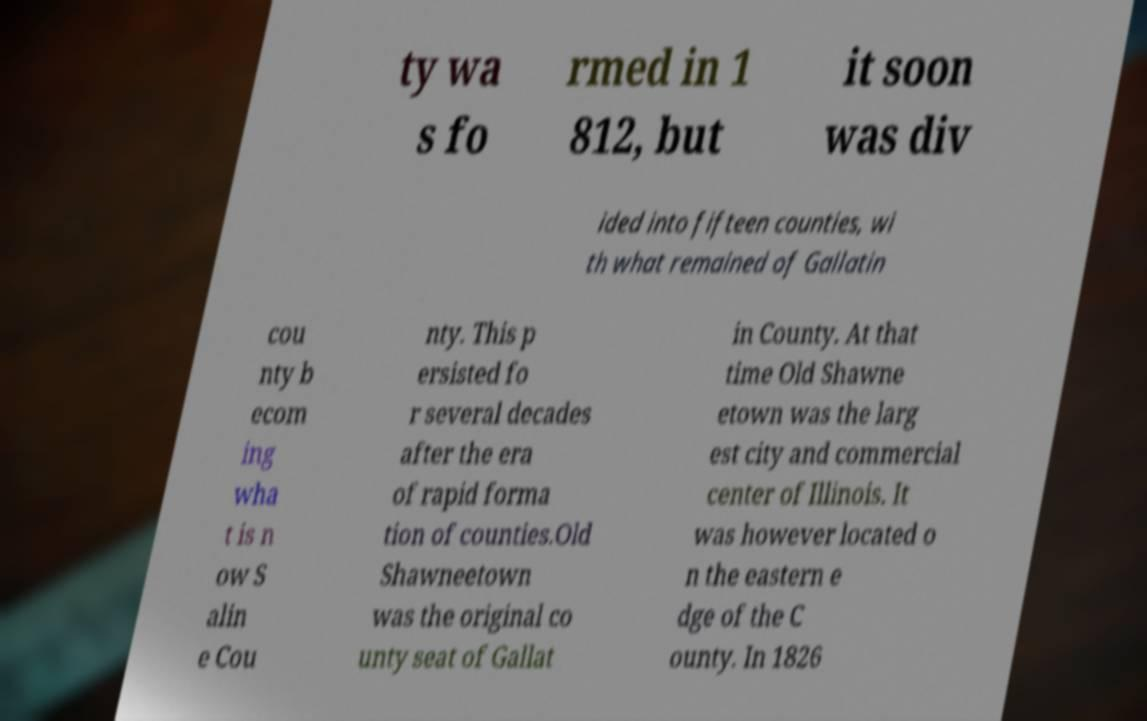For documentation purposes, I need the text within this image transcribed. Could you provide that? ty wa s fo rmed in 1 812, but it soon was div ided into fifteen counties, wi th what remained of Gallatin cou nty b ecom ing wha t is n ow S alin e Cou nty. This p ersisted fo r several decades after the era of rapid forma tion of counties.Old Shawneetown was the original co unty seat of Gallat in County. At that time Old Shawne etown was the larg est city and commercial center of Illinois. It was however located o n the eastern e dge of the C ounty. In 1826 